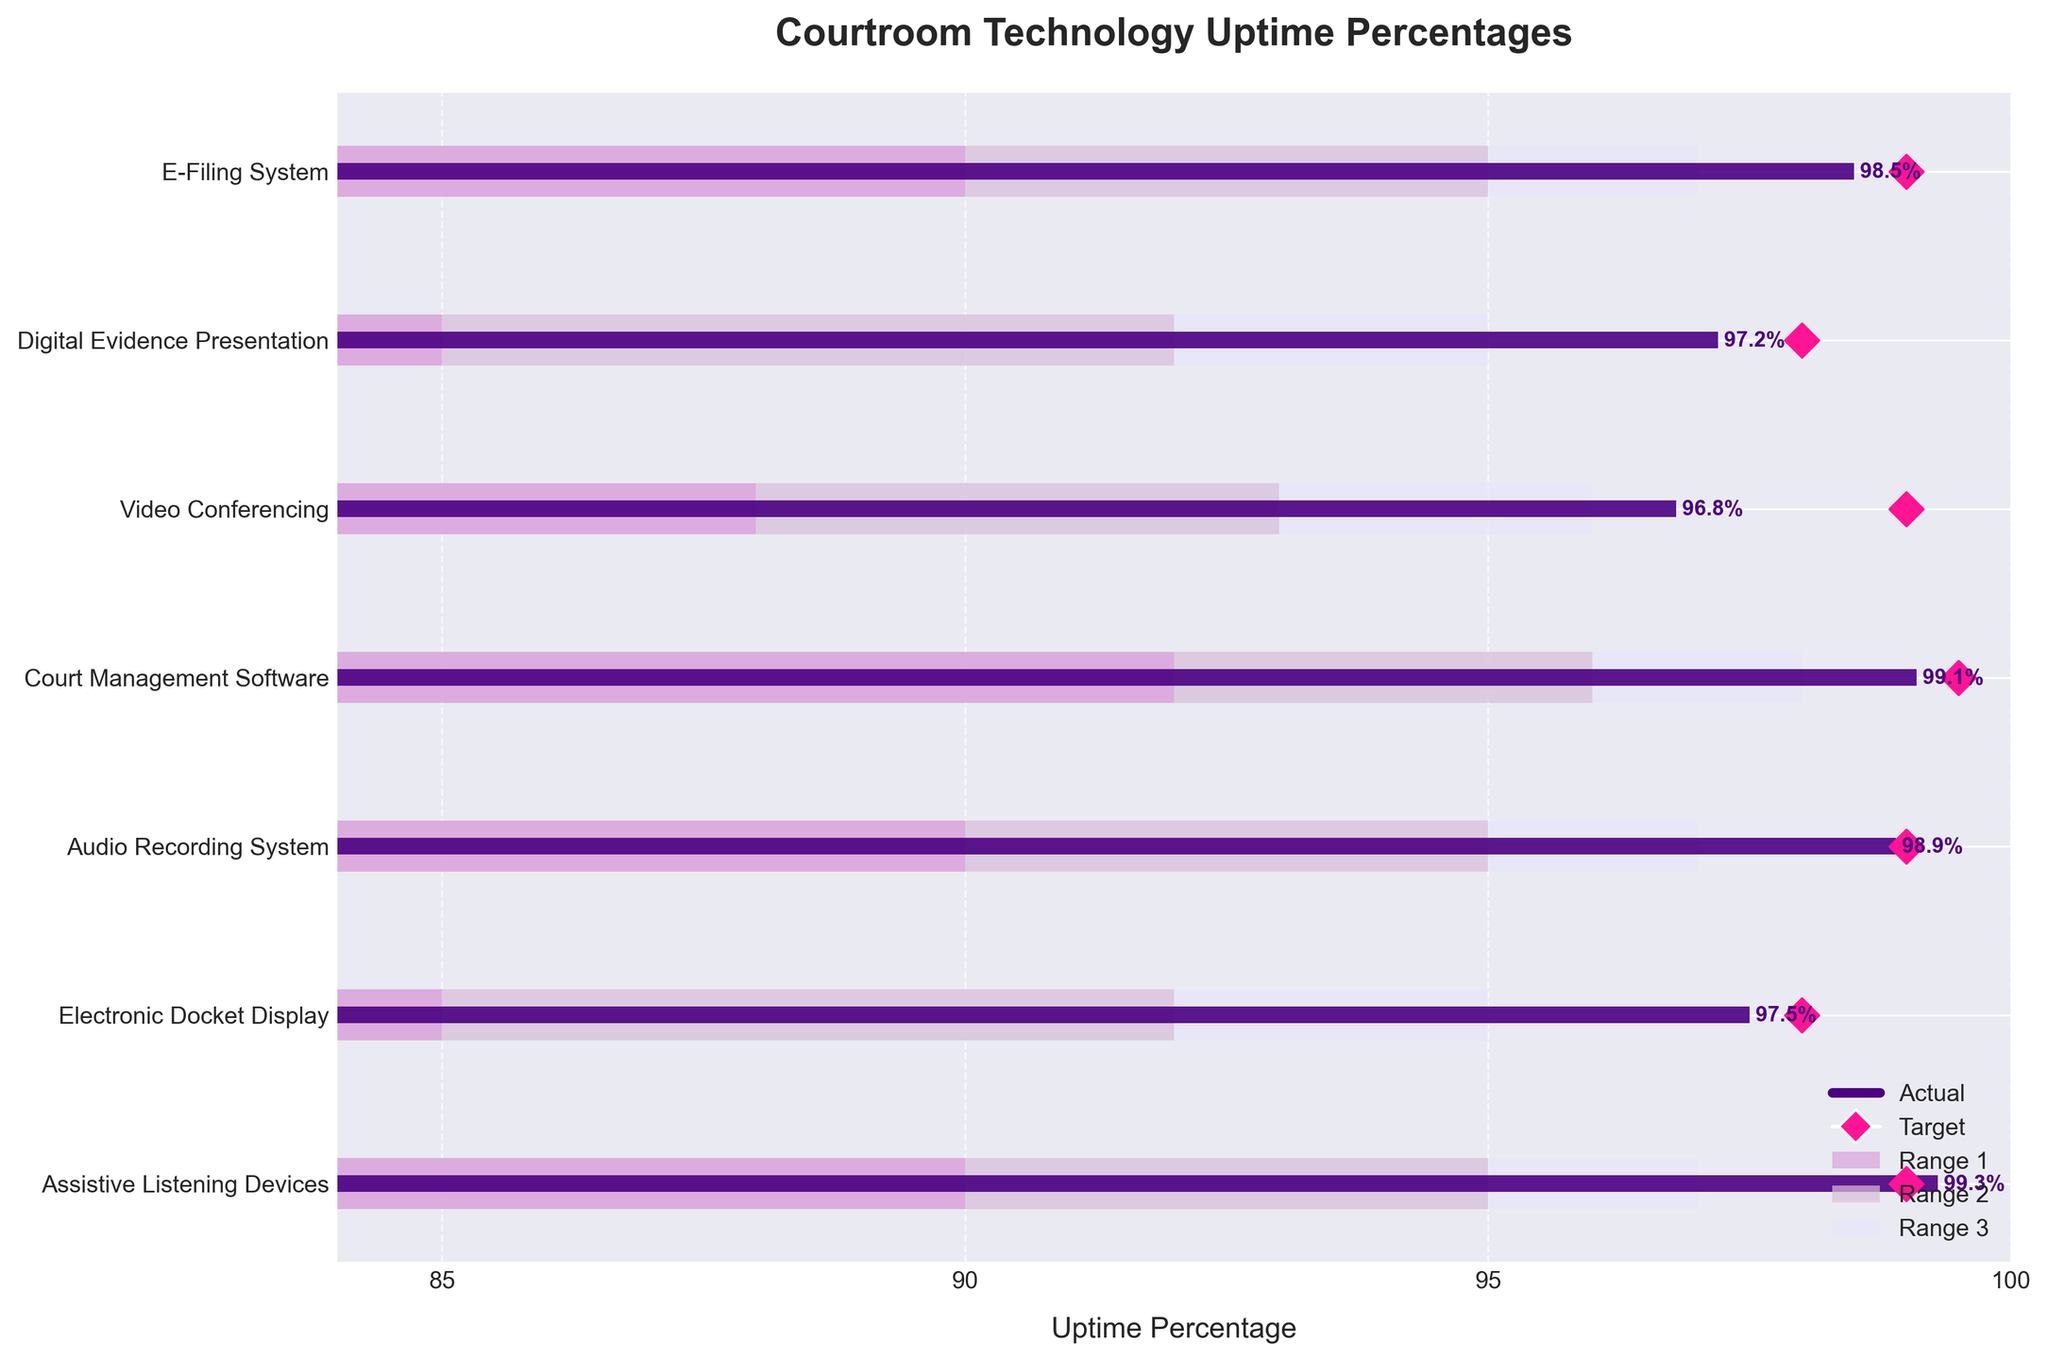What's the title of the figure? The title is displayed at the top of the figure and typically summarizes the main topic or purpose of the chart.
Answer: Courtroom Technology Uptime Percentages Which technology has the highest actual uptime percentage? By looking at the 'Actual' bars, the longest bar corresponds to the technology with the highest uptime percentage.
Answer: Assistive Listening Devices What is the target uptime percentage for the Digital Evidence Presentation system? The target uptime percentage is represented by the diamond marker on the bar corresponding to the Digital Evidence Presentation system.
Answer: 98 How many technologies have a target uptime of 99% or more? Count the number of diamond markers positioned at or above the 99% mark on the x-axis.
Answer: Three What are the three color-coded ranges in the bars meant to represent? Typically, bullet charts use different shades to represent performance ranges. The colors used might indicate thresholds like 'Acceptable,' 'Good,' and 'Excellent.'
Answer: Range 1, Range 2, and Range 3 How does the actual uptime of the E-Filing System compare to its target? Observe the 'Actual' bar length for the E-Filing System and compare it to the position of the diamond marker representing the target.
Answer: The actual uptime is below the target Which technology's actual uptime is closest to its target? Compare the lengths of the 'Actual' and target markers for each technology, focusing on finding the smallest difference.
Answer: Court Management Software What range category does the actual uptime of the Video Conferencing system fall into? Analyze the length of the 'Actual' bar for Video Conferencing and see which color-coded range it falls under.
Answer: Range 3 What is the average actual uptime percentage for the technologies presented? Add all the actual uptime percentages and divide by the number of technologies listed. The sum of actual percentages = 98.5 + 97.2 + 96.8 + 99.1 + 98.9 + 97.5 + 99.3 = 687.3. There are 7 technologies. Therefore, the average = 687.3 / 7 = 98.2.
Answer: 98.2 Which technology shows the biggest gap between its actual uptime and target? Determine the difference between the actual uptime and the target for each technology and identify the one with the largest gap. The gaps are as follows: E-Filing System (99 - 98.5 = 0.5), Digital Evidence Presentation (98 - 97.2 = 0.8), Video Conferencing (99 - 96.8 = 2.2), Court Management Software (99.5 - 99.1 = 0.4), Audio Recording System (99 - 98.9 = 0.1), Electronic Docket Display (98 - 97.5 = 0.5), Assistive Listening Devices (99 - 99.3 = -0.3). The largest positive gap is for Video Conferencing.
Answer: Video Conferencing 